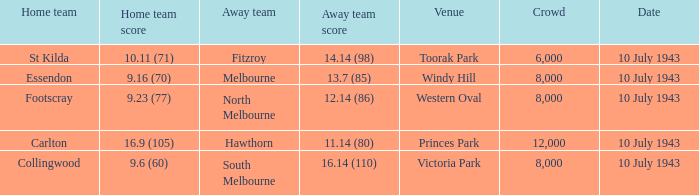When the Home team of carlton played, what was their score? 16.9 (105). 